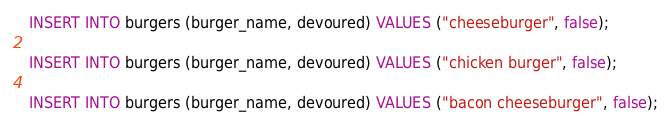Convert code to text. <code><loc_0><loc_0><loc_500><loc_500><_SQL_>INSERT INTO burgers (burger_name, devoured) VALUES ("cheeseburger", false);

INSERT INTO burgers (burger_name, devoured) VALUES ("chicken burger", false);

INSERT INTO burgers (burger_name, devoured) VALUES ("bacon cheeseburger", false);</code> 